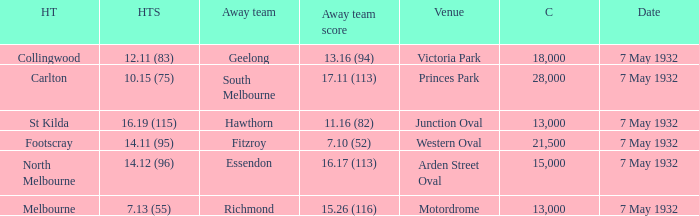12 (96)? 15000.0. 